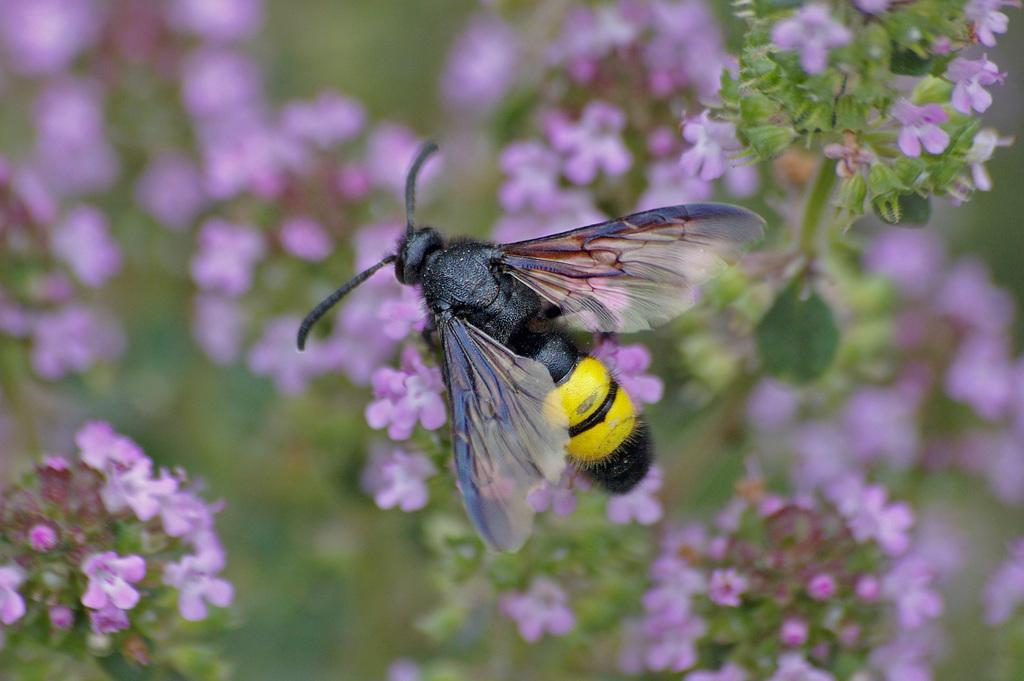What type of creature is present in the image? There is an insect in the image. Where is the insect located? The insect is on a bunch of flowers. What can be seen in the background of the image? There are flowers on plants in the background of the image. What type of guitar is the insect playing in the image? There is no guitar present in the image; it features an insect on a bunch of flowers. Can you tell me how many ears are visible in the image? There are no ears visible in the image. 